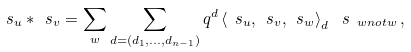Convert formula to latex. <formula><loc_0><loc_0><loc_500><loc_500>\ s _ { u } * \ s _ { v } = \sum _ { w } \sum _ { d = ( d _ { 1 } , \dots , d _ { n - 1 } ) } q ^ { d } \left < \ s _ { u } , \ s _ { v } , \ s _ { w } \right > _ { d } \, \ s _ { \ w n o t w } \, ,</formula> 